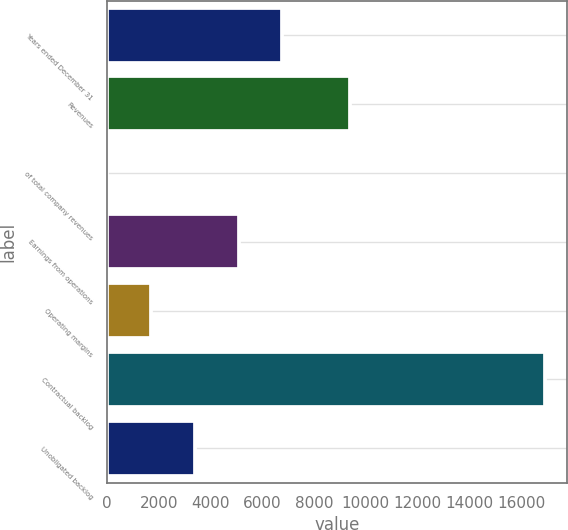Convert chart. <chart><loc_0><loc_0><loc_500><loc_500><bar_chart><fcel>Years ended December 31<fcel>Revenues<fcel>of total company revenues<fcel>Earnings from operations<fcel>Operating margins<fcel>Contractual backlog<fcel>Unobligated backlog<nl><fcel>6774<fcel>9378<fcel>10<fcel>5083<fcel>1701<fcel>16920<fcel>3392<nl></chart> 